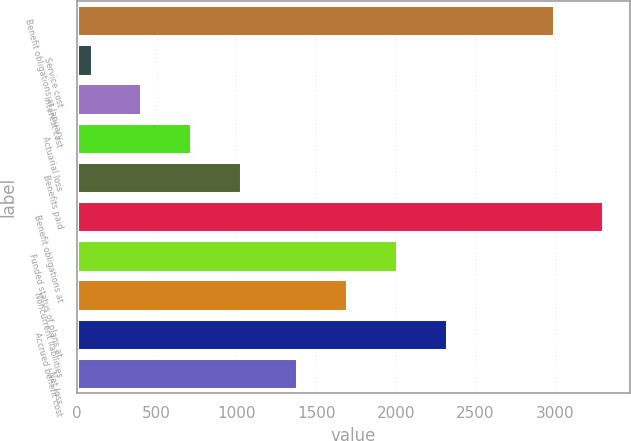Convert chart. <chart><loc_0><loc_0><loc_500><loc_500><bar_chart><fcel>Benefit obligations at January<fcel>Service cost<fcel>Interest cost<fcel>Actuarial loss<fcel>Benefits paid<fcel>Benefit obligations at<fcel>Funded status of plans at<fcel>Noncurrent liabilities<fcel>Accrued benefit cost<fcel>Net loss<nl><fcel>2989<fcel>92<fcel>404.9<fcel>717.8<fcel>1030.7<fcel>3301.9<fcel>2007.8<fcel>1694.9<fcel>2320.7<fcel>1382<nl></chart> 